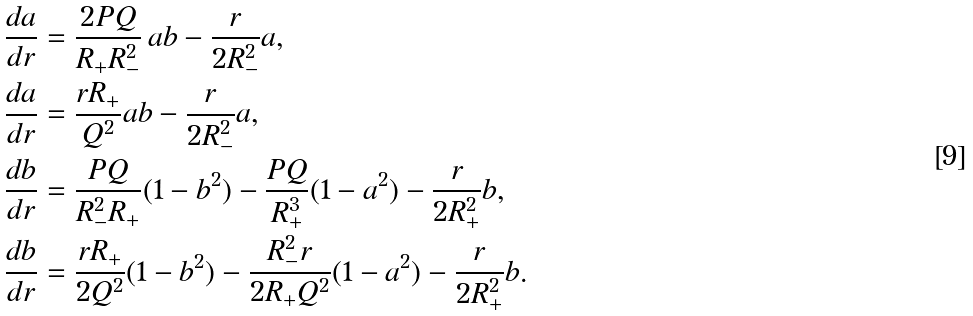<formula> <loc_0><loc_0><loc_500><loc_500>& \frac { d a } { d r } = \frac { 2 P Q } { R _ { + } R _ { - } ^ { 2 } } \, a b - \frac { r } { 2 R _ { - } ^ { 2 } } a , \\ & \frac { d a } { d r } = \frac { r R _ { + } } { Q ^ { 2 } } a b - \frac { r } { 2 R _ { - } ^ { 2 } } a , \\ & \frac { d b } { d r } = \frac { P Q } { R _ { - } ^ { 2 } R _ { + } } ( 1 - b ^ { 2 } ) - \frac { P Q } { R _ { + } ^ { 3 } } ( 1 - a ^ { 2 } ) - \frac { r } { 2 R _ { + } ^ { 2 } } b , \\ & \frac { d b } { d r } = \frac { r R _ { + } } { 2 Q ^ { 2 } } ( 1 - b ^ { 2 } ) - \frac { R _ { - } ^ { 2 } r } { 2 R _ { + } Q ^ { 2 } } ( 1 - a ^ { 2 } ) - \frac { r } { 2 R _ { + } ^ { 2 } } b .</formula> 